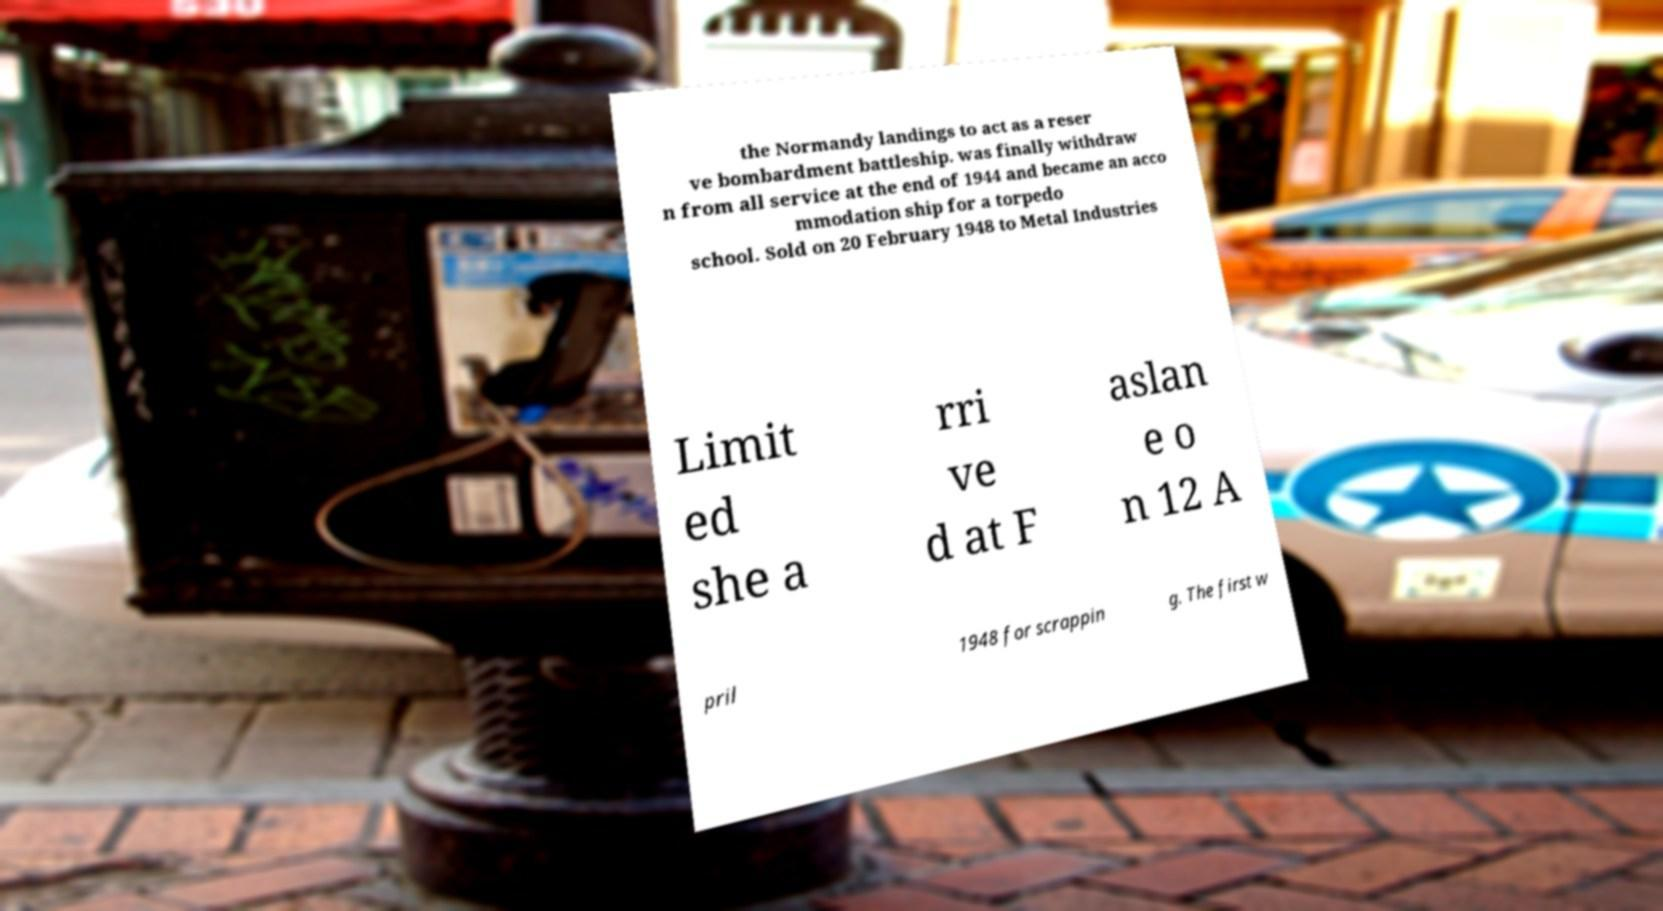Please read and relay the text visible in this image. What does it say? the Normandy landings to act as a reser ve bombardment battleship. was finally withdraw n from all service at the end of 1944 and became an acco mmodation ship for a torpedo school. Sold on 20 February 1948 to Metal Industries Limit ed she a rri ve d at F aslan e o n 12 A pril 1948 for scrappin g. The first w 